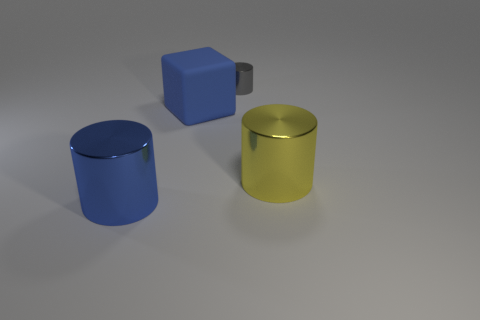What size is the blue metal thing that is the same shape as the yellow object?
Provide a succinct answer. Large. Do the matte object and the cylinder to the left of the small cylinder have the same color?
Make the answer very short. Yes. The big block is what color?
Your response must be concise. Blue. Is there anything else that has the same shape as the large blue rubber object?
Keep it short and to the point. No. The tiny metal object that is the same shape as the big blue metallic thing is what color?
Your response must be concise. Gray. Do the blue metallic object and the yellow metallic object have the same shape?
Provide a succinct answer. Yes. How many blocks are either small gray shiny things or shiny objects?
Make the answer very short. 0. There is another large cylinder that is made of the same material as the yellow cylinder; what is its color?
Your answer should be compact. Blue. There is a metal thing that is in front of the yellow shiny cylinder; is its size the same as the blue matte block?
Offer a very short reply. Yes. Is the gray cylinder made of the same material as the big blue object on the right side of the big blue metal object?
Offer a terse response. No. 